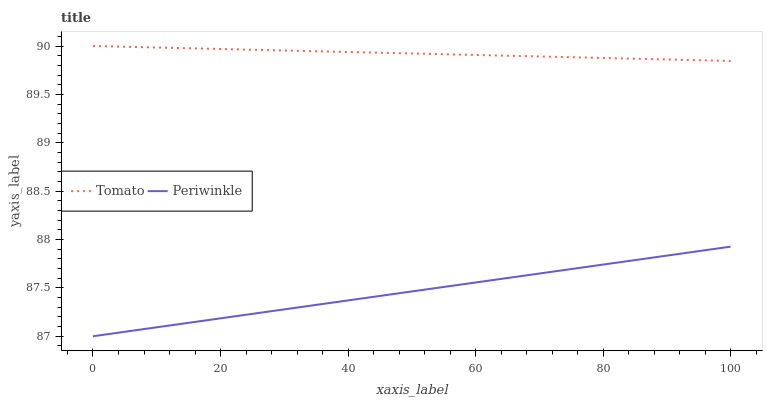Does Periwinkle have the minimum area under the curve?
Answer yes or no. Yes. Does Tomato have the maximum area under the curve?
Answer yes or no. Yes. Does Periwinkle have the maximum area under the curve?
Answer yes or no. No. Is Periwinkle the smoothest?
Answer yes or no. Yes. Is Tomato the roughest?
Answer yes or no. Yes. Is Periwinkle the roughest?
Answer yes or no. No. Does Periwinkle have the lowest value?
Answer yes or no. Yes. Does Tomato have the highest value?
Answer yes or no. Yes. Does Periwinkle have the highest value?
Answer yes or no. No. Is Periwinkle less than Tomato?
Answer yes or no. Yes. Is Tomato greater than Periwinkle?
Answer yes or no. Yes. Does Periwinkle intersect Tomato?
Answer yes or no. No. 